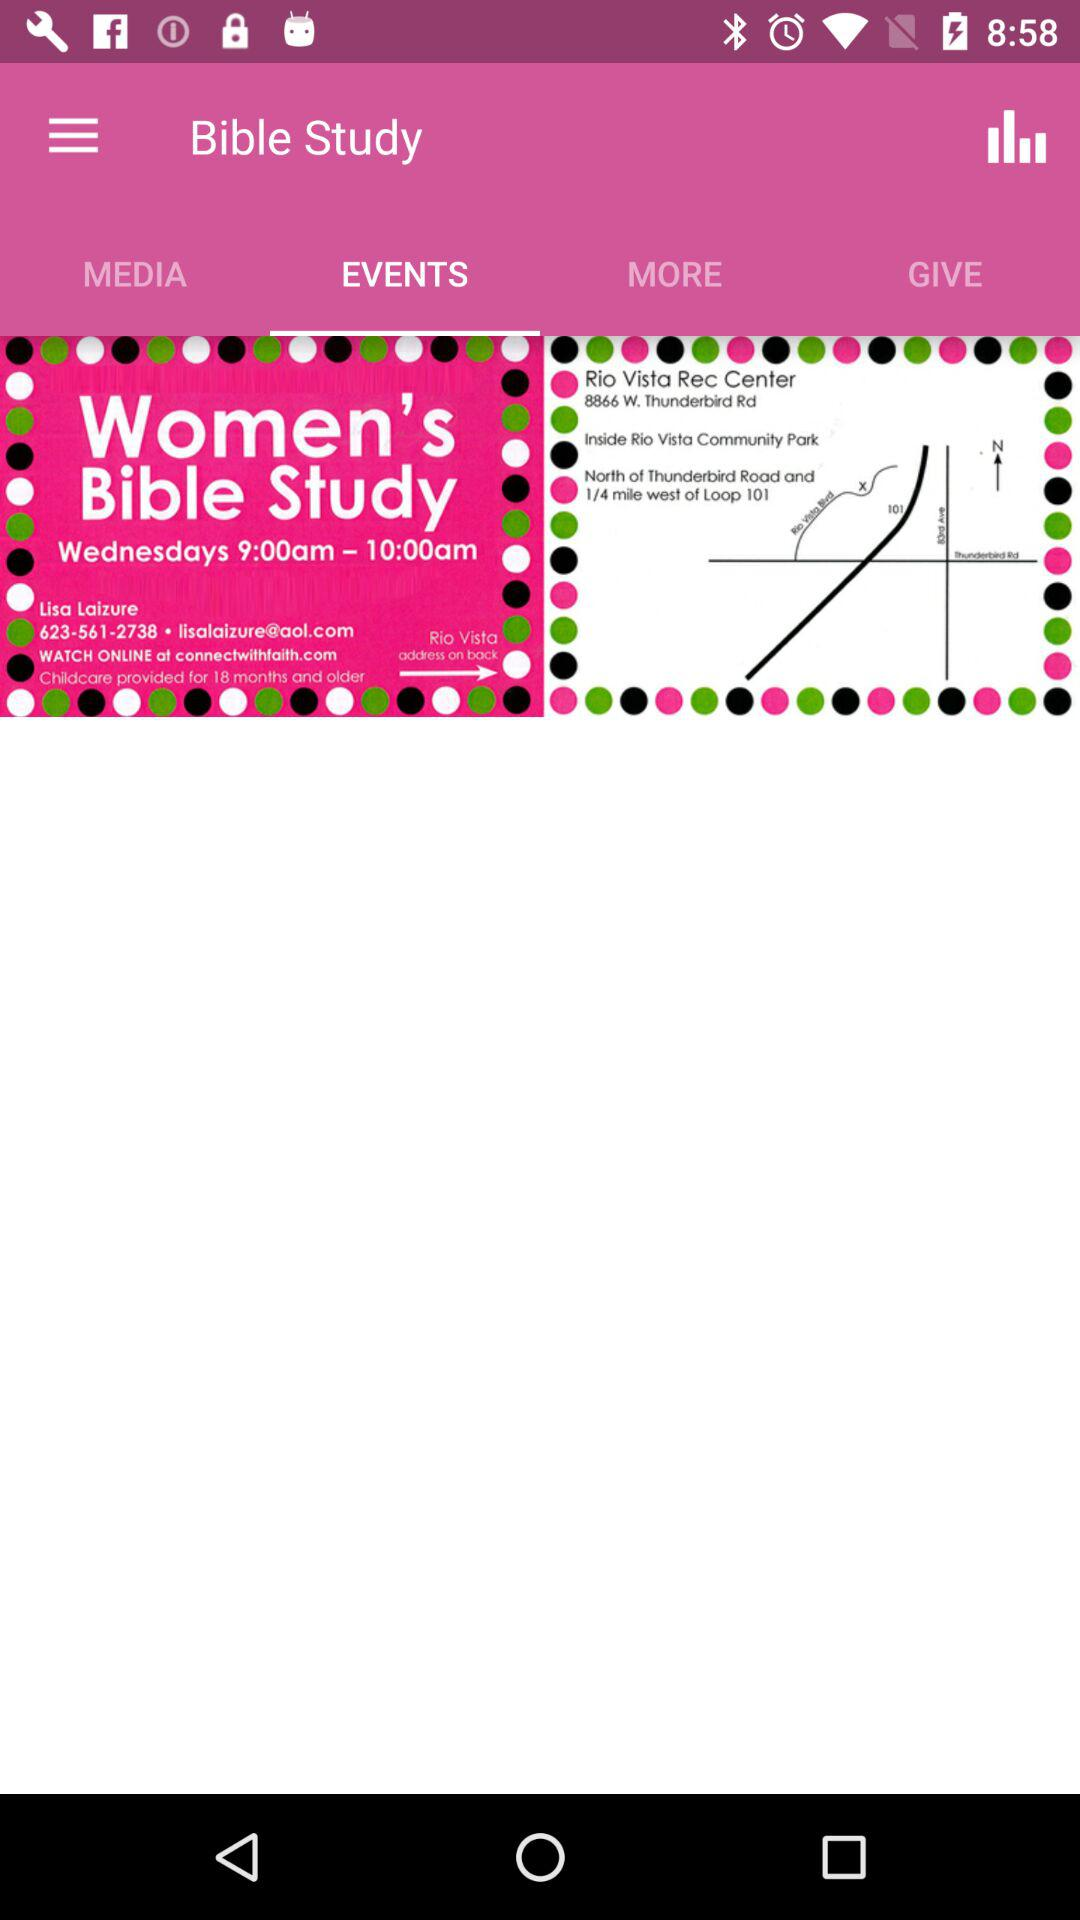What tab am I on? You are on the "EVENTS" tab. 